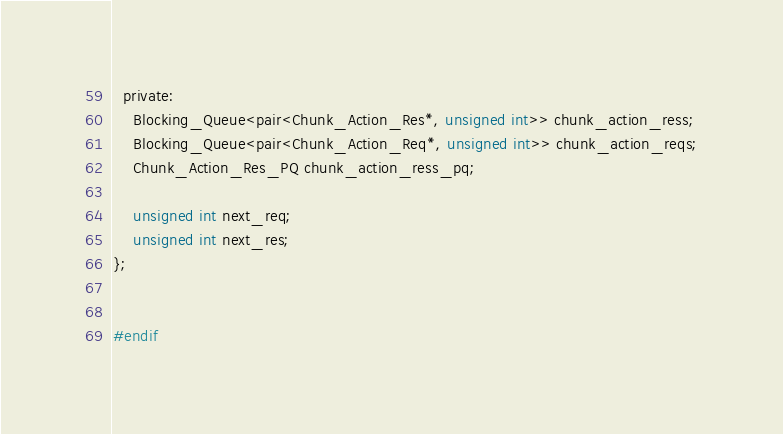Convert code to text. <code><loc_0><loc_0><loc_500><loc_500><_C_>  private:
    Blocking_Queue<pair<Chunk_Action_Res*, unsigned int>> chunk_action_ress;
    Blocking_Queue<pair<Chunk_Action_Req*, unsigned int>> chunk_action_reqs;
    Chunk_Action_Res_PQ chunk_action_ress_pq;

    unsigned int next_req;
    unsigned int next_res;
};


#endif
</code> 